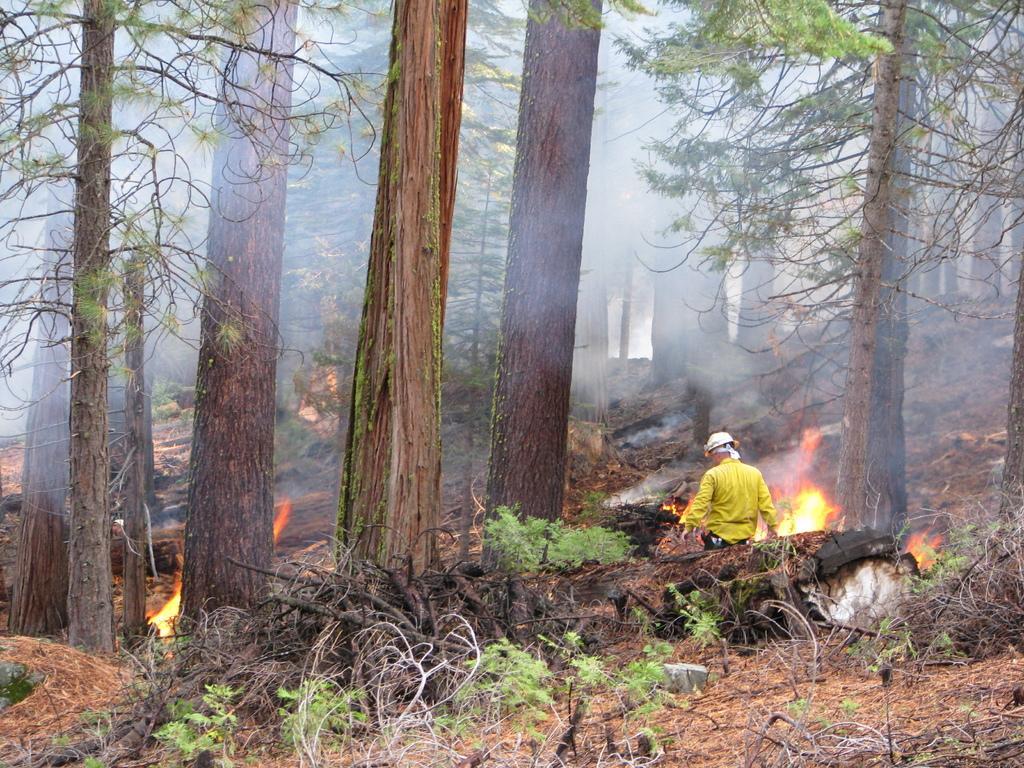Can you describe this image briefly? This is an outside view. At the bottom there are some plants. On the right side there is a person standing facing towards the back side. In front of him I can see the fire. In the background there are many trees. 